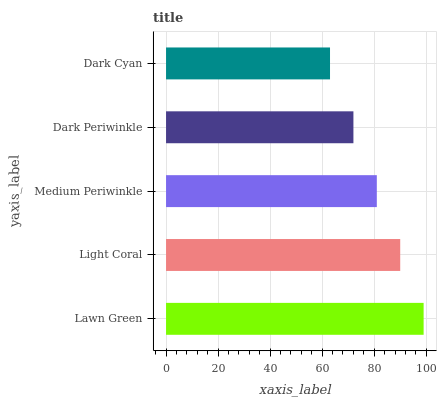Is Dark Cyan the minimum?
Answer yes or no. Yes. Is Lawn Green the maximum?
Answer yes or no. Yes. Is Light Coral the minimum?
Answer yes or no. No. Is Light Coral the maximum?
Answer yes or no. No. Is Lawn Green greater than Light Coral?
Answer yes or no. Yes. Is Light Coral less than Lawn Green?
Answer yes or no. Yes. Is Light Coral greater than Lawn Green?
Answer yes or no. No. Is Lawn Green less than Light Coral?
Answer yes or no. No. Is Medium Periwinkle the high median?
Answer yes or no. Yes. Is Medium Periwinkle the low median?
Answer yes or no. Yes. Is Dark Cyan the high median?
Answer yes or no. No. Is Dark Periwinkle the low median?
Answer yes or no. No. 